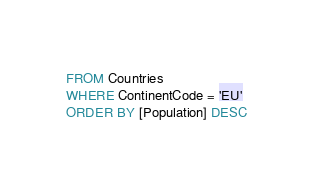Convert code to text. <code><loc_0><loc_0><loc_500><loc_500><_SQL_>FROM Countries
WHERE ContinentCode = 'EU'
ORDER BY [Population] DESC</code> 